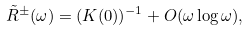Convert formula to latex. <formula><loc_0><loc_0><loc_500><loc_500>\tilde { R } ^ { \pm } ( \omega ) = ( K ( 0 ) ) ^ { - 1 } + O ( \omega \log \omega ) ,</formula> 